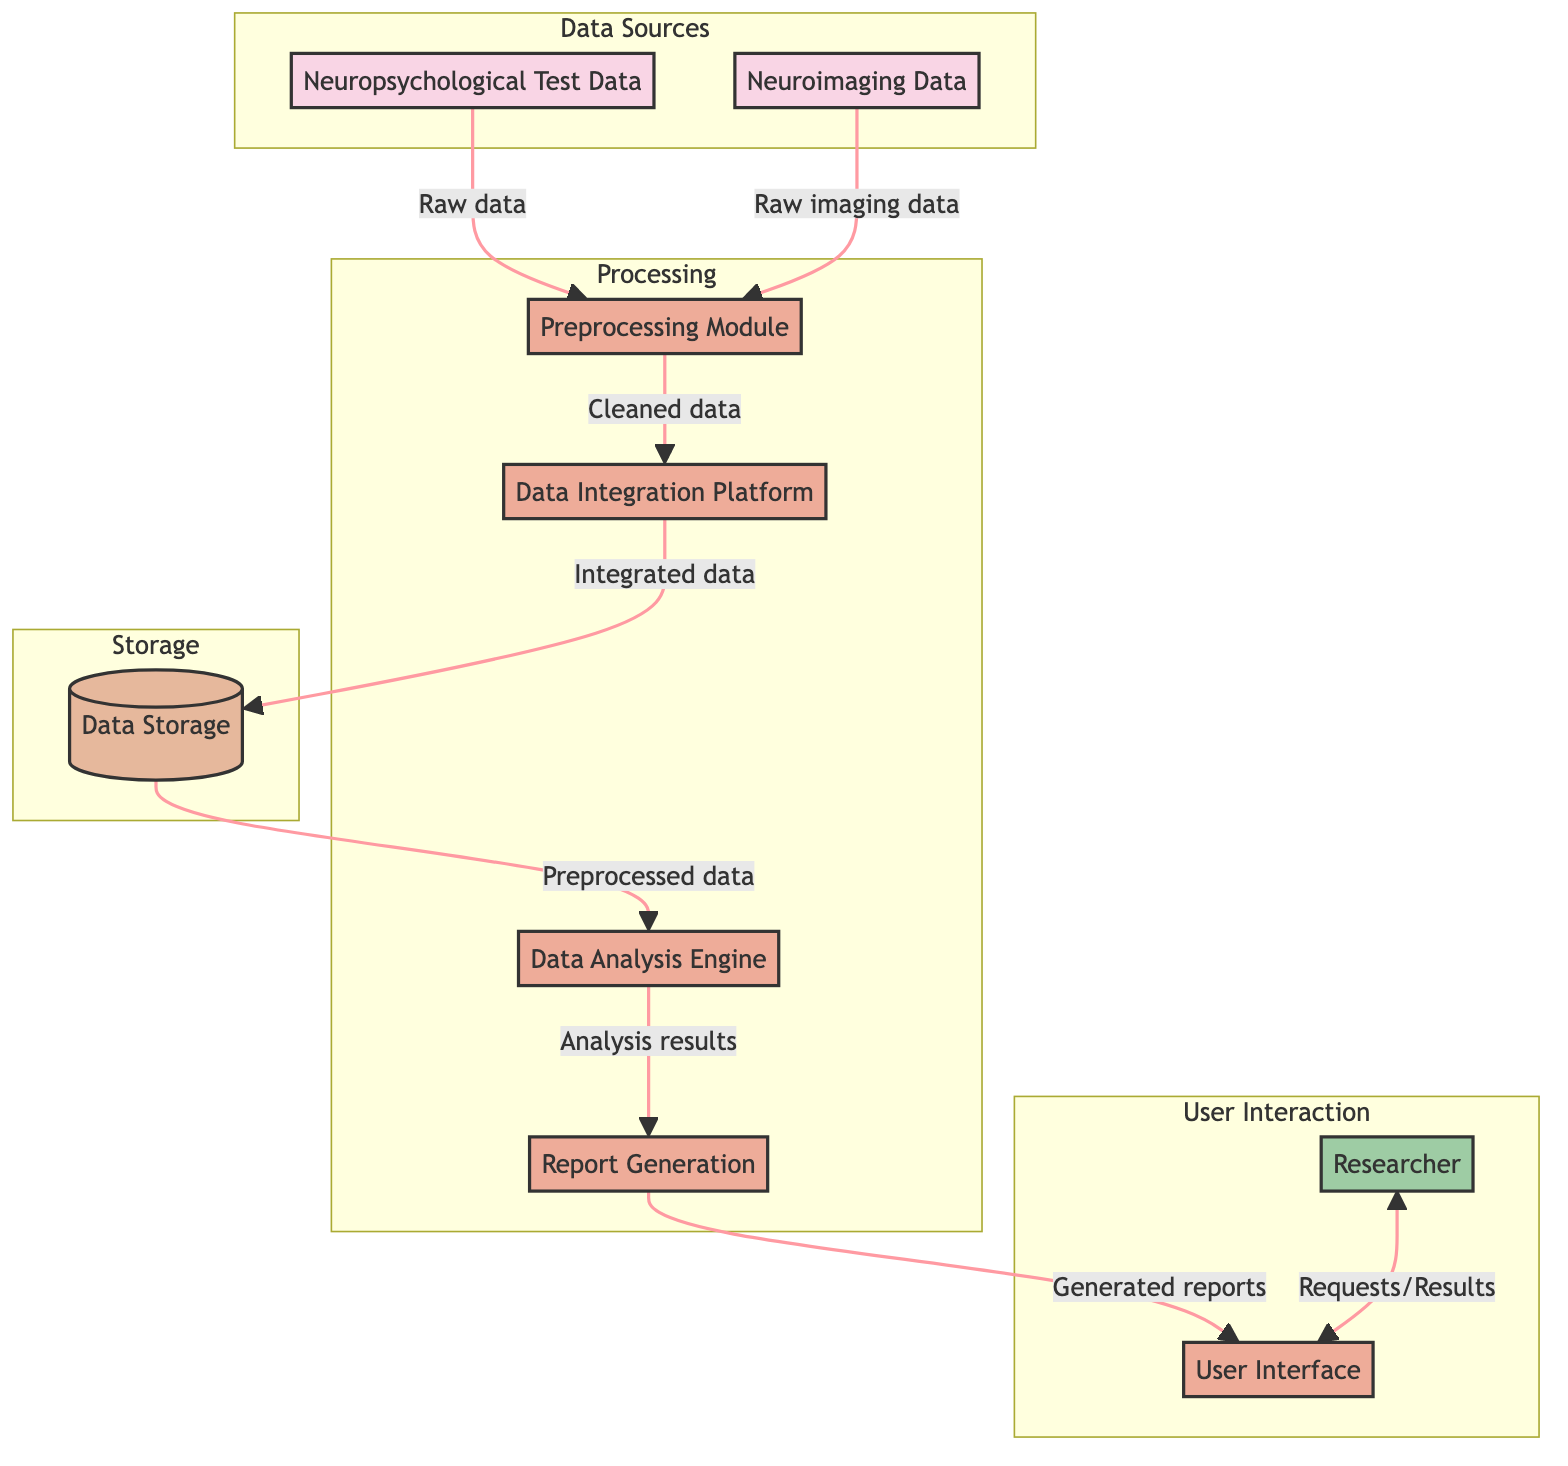What is the total number of data sources in the diagram? The diagram specifies two data sources: Neuropsychological Test Data and Neuroimaging Data.
Answer: 2 Which process receives cleaned data from the preprocessing module? The Preprocessing Module outputs cleaned and normalized data to the Data Integration Platform, as indicated by the directed flow from PM to DIP.
Answer: Data Integration Platform What is the primary output of the data analysis engine? The Data Analysis Engine produces analysis results that flow into the Report Generation process, as shown by the direct connection between DAE and RG.
Answer: Analysis results Who interacts with the system to request analyses? The Researcher is identified as the external entity that requests data queries and analyses through the User Interface, as indicated by the directed edge from R to UI.
Answer: Researcher What is stored in the data storage process? The Data Storage process holds integrated and processed data that comes from the Data Integration Platform, as demonstrated by the flow from DIP to DS.
Answer: Integrated data What is the immediate input for the preprocessing module? The Preprocessing Module receives two immediate inputs: raw data from Neuropsychological Test Data and raw imaging data from Neuroimaging Data, indicated by flows leading into PM.
Answer: Raw data and raw imaging data Which process automatically compiles analysis results into reports? The Report Generation process compiles analysis results from the Data Analysis Engine, as shown by the direct flow from DAE to RG.
Answer: Report Generation Where do generated reports go after completion? Generated reports from the Report Generation process are sent to the User Interface, as indicated by the flow from RG to UI.
Answer: User Interface How many processes are involved in the workflow? The diagram identifies five distinct processes: Preprocessing Module, Data Integration Platform, Data Analysis Engine, Report Generation, and User Interface.
Answer: 5 